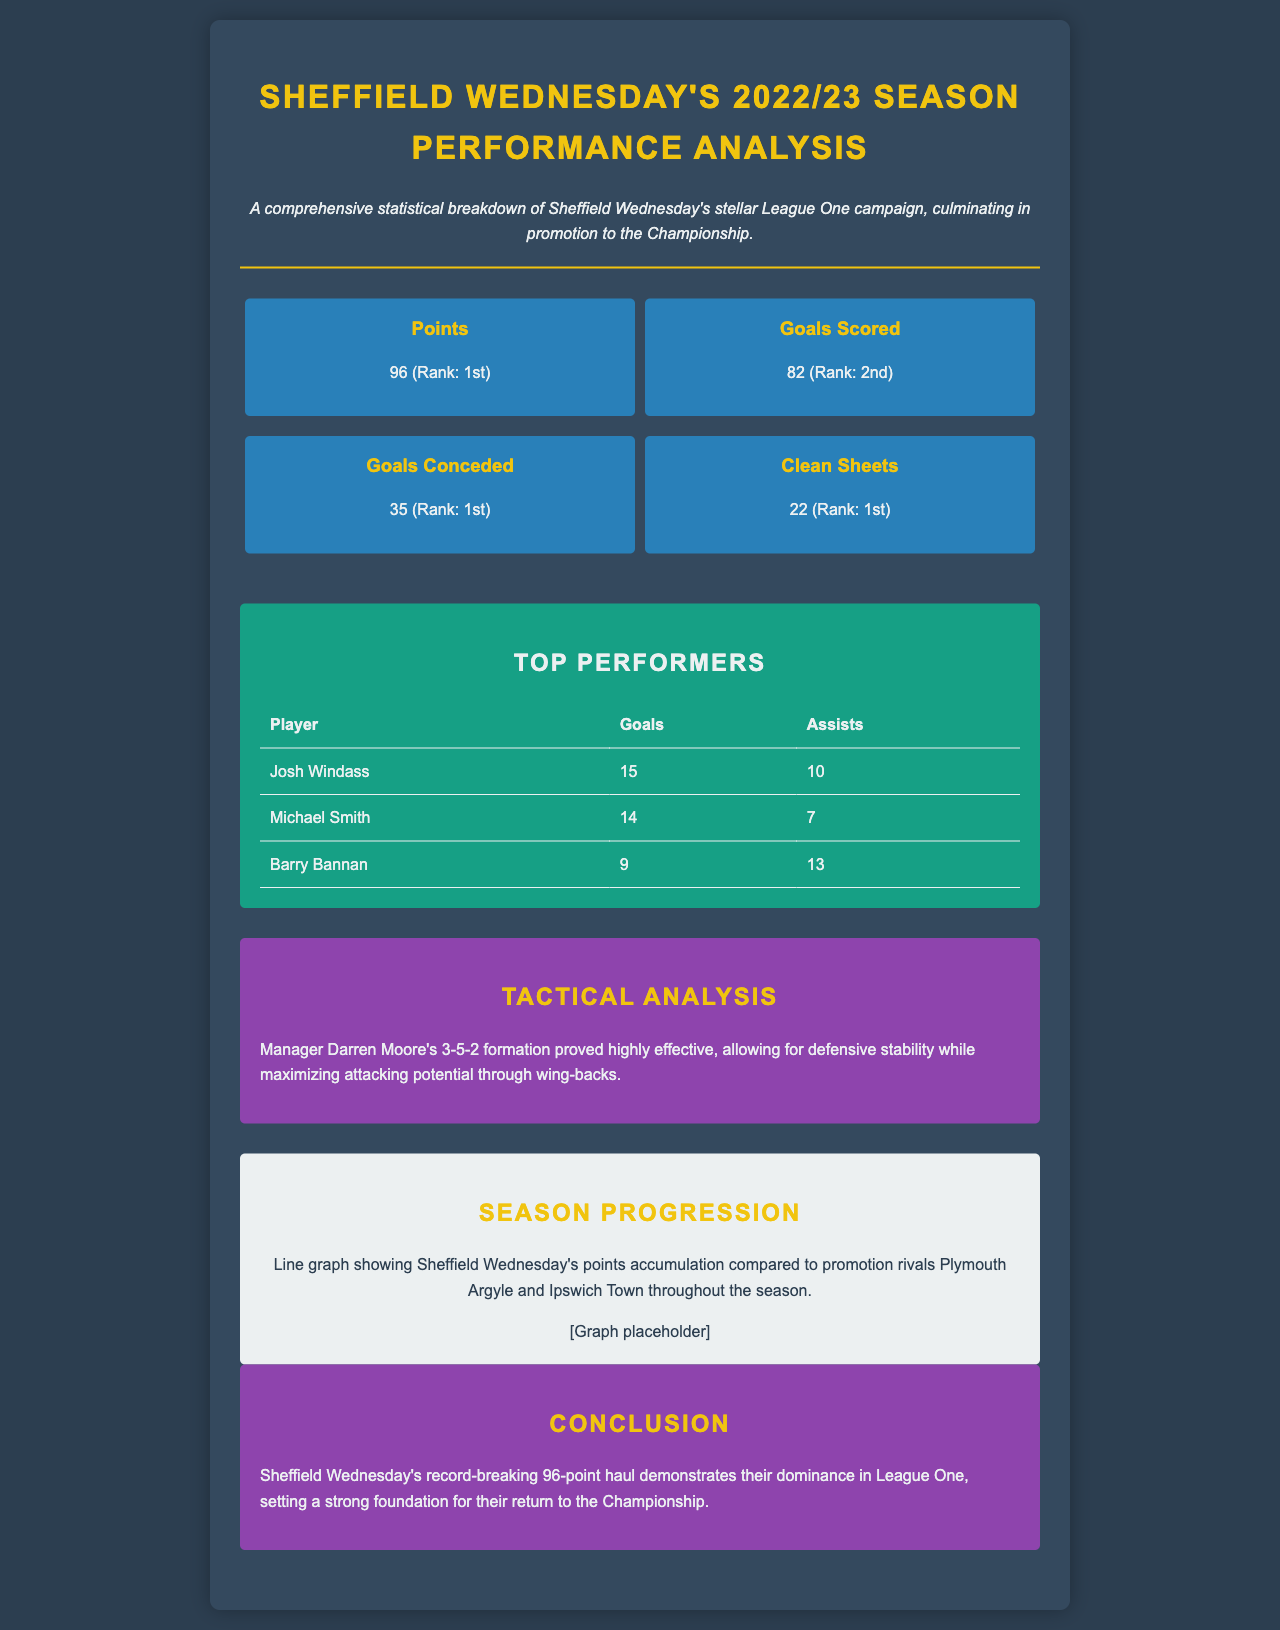What was Sheffield Wednesday's points total? The document states that Sheffield Wednesday accumulated 96 points during the season.
Answer: 96 Which player scored the most goals for Sheffield Wednesday? According to the table of top performers, Josh Windass scored the highest number of goals at 15.
Answer: Josh Windass What formation did Sheffield Wednesday use under manager Darren Moore? The tactical analysis section describes the effective 3-5-2 formation as utilized by Moore.
Answer: 3-5-2 How many clean sheets did Sheffield Wednesday achieve? The statistics section declares that the team managed to keep 22 clean sheets throughout the season.
Answer: 22 Who provided the most assists for Sheffield Wednesday? The top performers table shows that Barry Bannan achieved the most assists, totaling 13.
Answer: Barry Bannan What rank did Sheffield Wednesday achieve for goals conceded? In the statistics section, it indicates that Sheffield Wednesday ranked 1st for goals conceded during the season.
Answer: 1st How many goals did Michael Smith score? The table of top performers reports that Michael Smith scored 14 goals during the season.
Answer: 14 Which team had the highest points total in League One? The document states that Sheffield Wednesday had the highest points total with 96 points, thus ranking 1st.
Answer: 1st What is a key feature of Sheffield Wednesday’s tactical approach? The tactical analysis emphasizes defensive stability and attacking potential through the use of wing-backs.
Answer: Defensive stability 